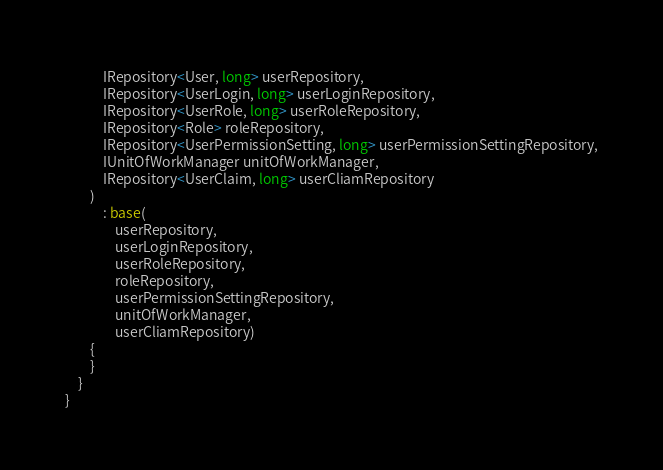<code> <loc_0><loc_0><loc_500><loc_500><_C#_>            IRepository<User, long> userRepository,
            IRepository<UserLogin, long> userLoginRepository,
            IRepository<UserRole, long> userRoleRepository,
            IRepository<Role> roleRepository,
            IRepository<UserPermissionSetting, long> userPermissionSettingRepository,
            IUnitOfWorkManager unitOfWorkManager,
            IRepository<UserClaim, long> userCliamRepository
        )
            : base(
                userRepository,
                userLoginRepository,
                userRoleRepository,
                roleRepository,
                userPermissionSettingRepository,
                unitOfWorkManager,
                userCliamRepository)
        {
        }
    }
}</code> 